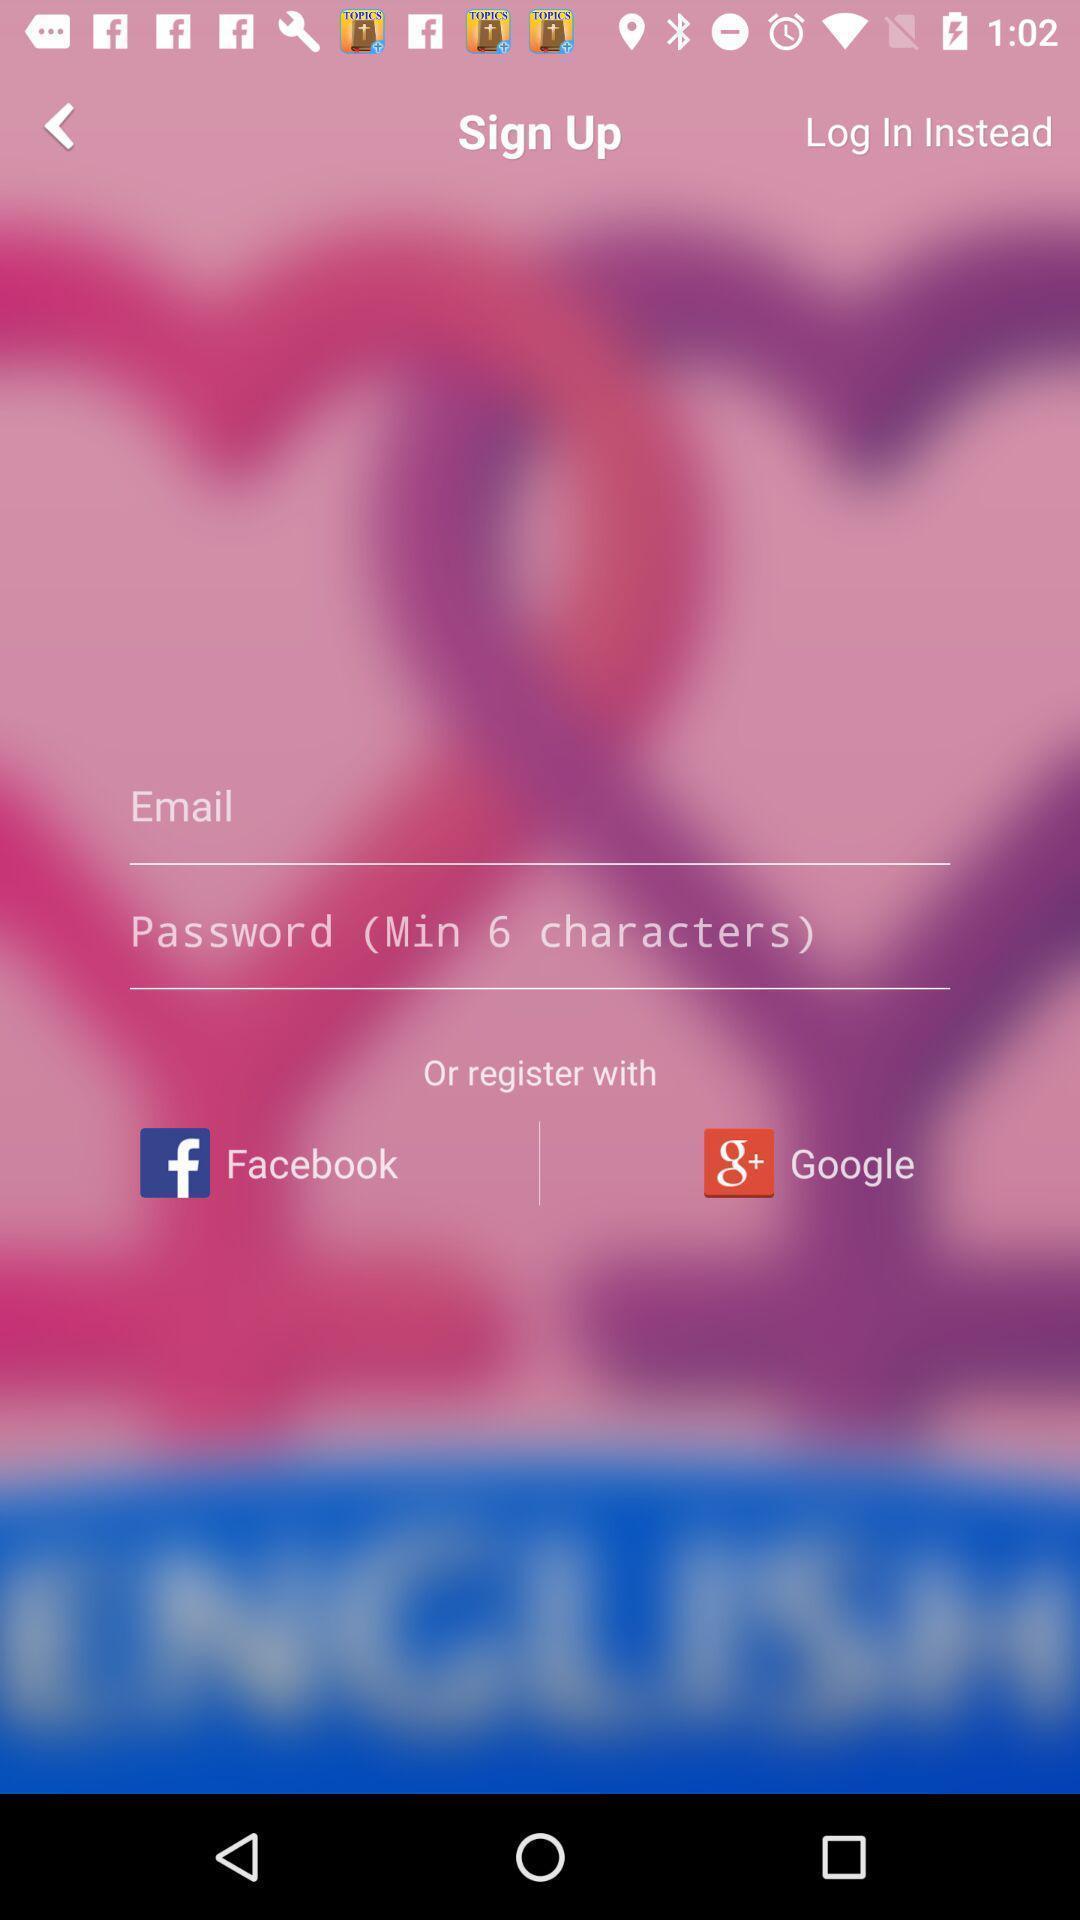Describe this image in words. Welcome page. 